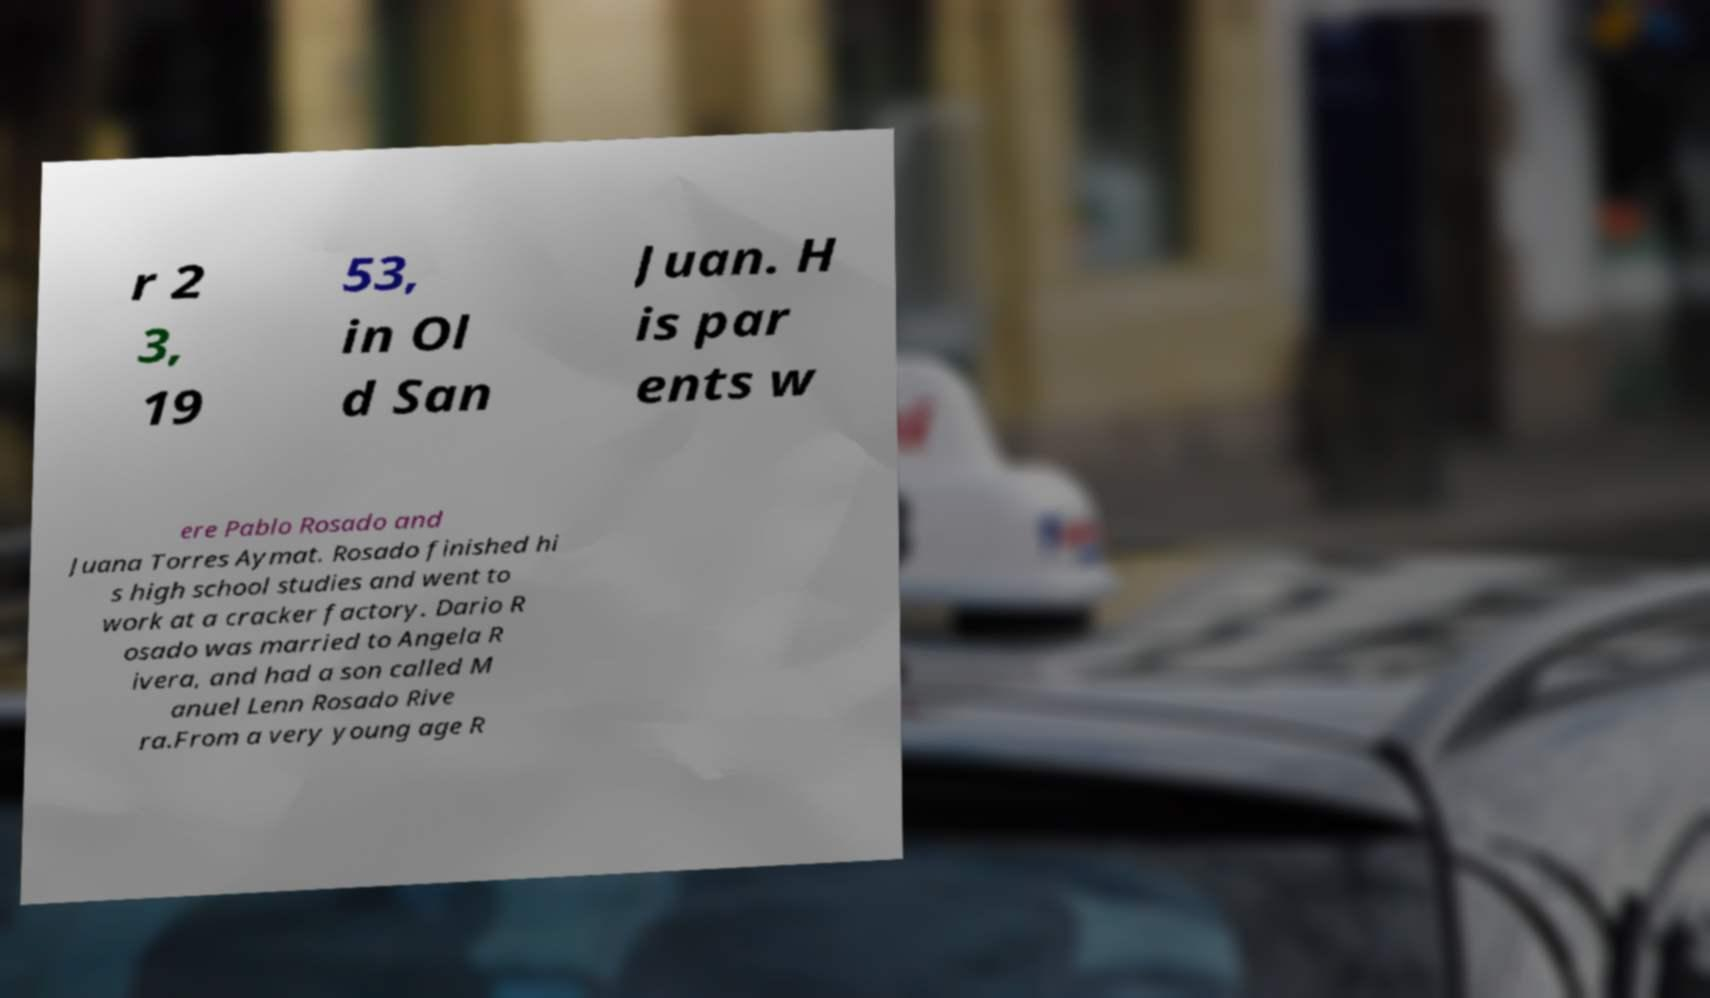Can you read and provide the text displayed in the image?This photo seems to have some interesting text. Can you extract and type it out for me? r 2 3, 19 53, in Ol d San Juan. H is par ents w ere Pablo Rosado and Juana Torres Aymat. Rosado finished hi s high school studies and went to work at a cracker factory. Dario R osado was married to Angela R ivera, and had a son called M anuel Lenn Rosado Rive ra.From a very young age R 